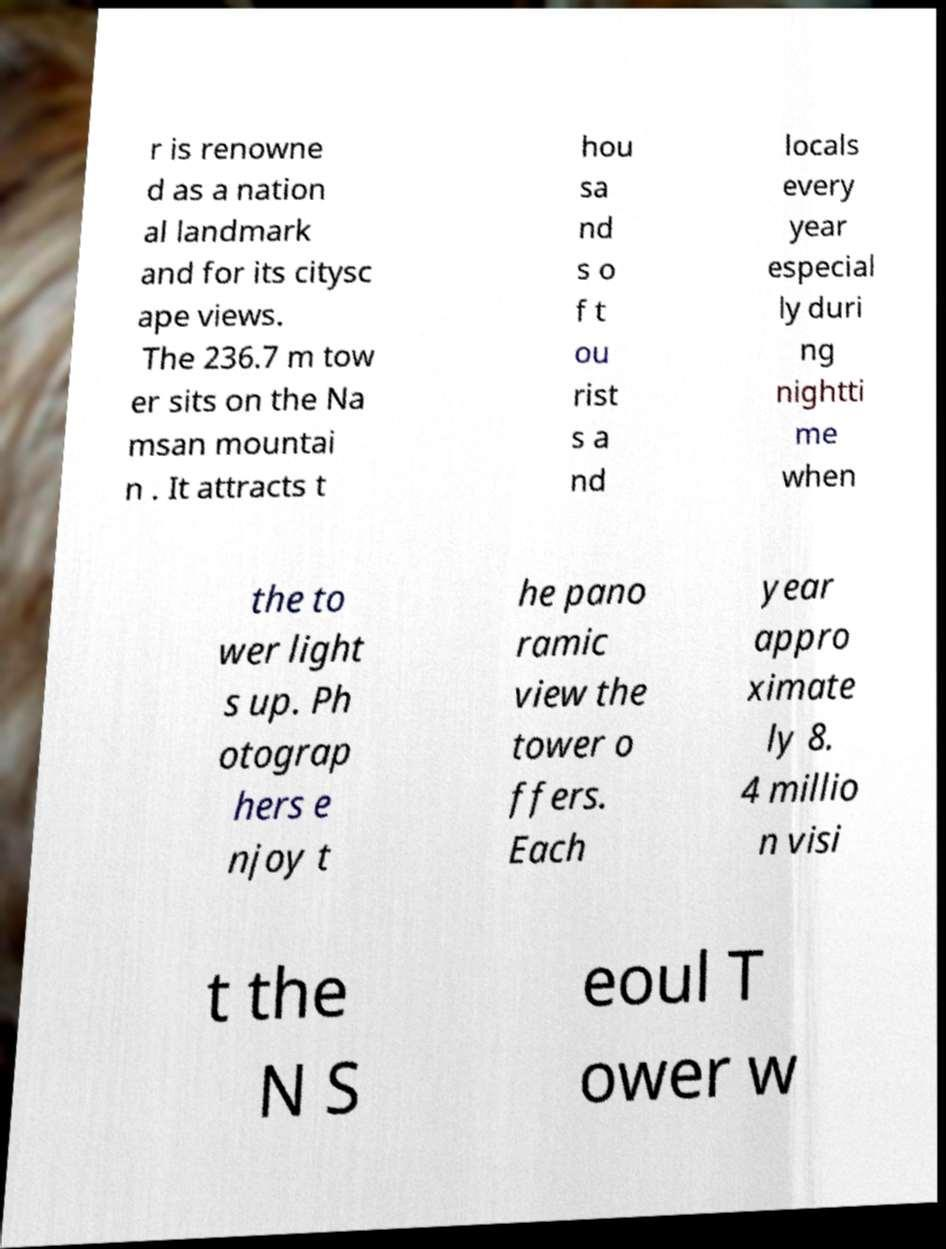Please read and relay the text visible in this image. What does it say? r is renowne d as a nation al landmark and for its citysc ape views. The 236.7 m tow er sits on the Na msan mountai n . It attracts t hou sa nd s o f t ou rist s a nd locals every year especial ly duri ng nightti me when the to wer light s up. Ph otograp hers e njoy t he pano ramic view the tower o ffers. Each year appro ximate ly 8. 4 millio n visi t the N S eoul T ower w 